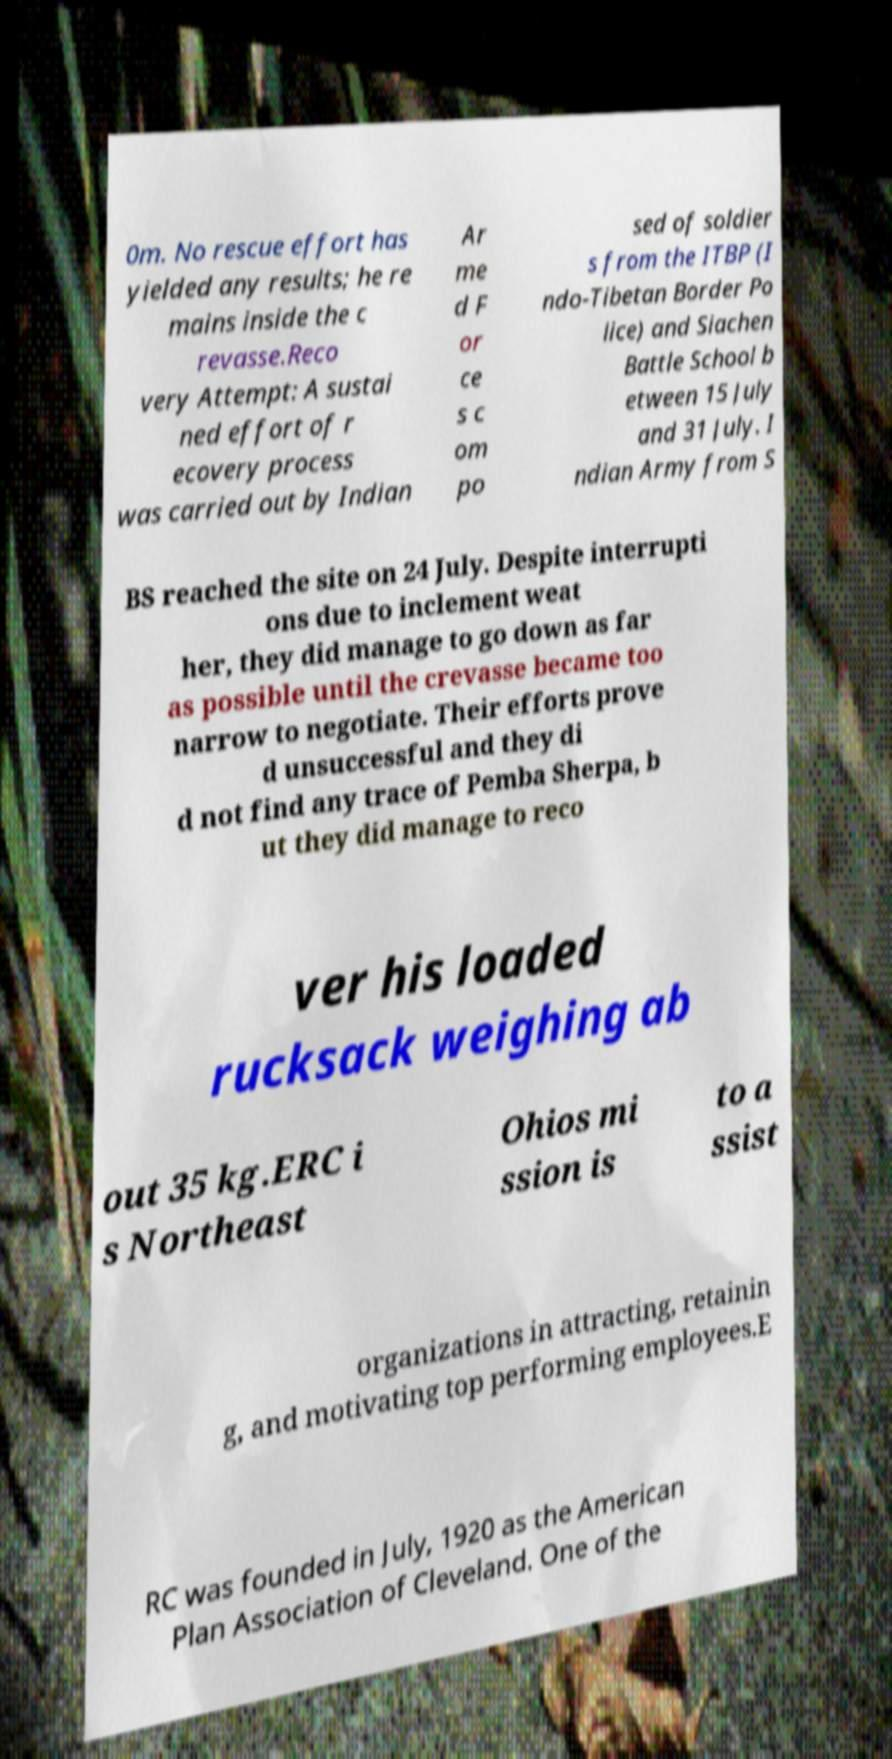Can you accurately transcribe the text from the provided image for me? 0m. No rescue effort has yielded any results; he re mains inside the c revasse.Reco very Attempt: A sustai ned effort of r ecovery process was carried out by Indian Ar me d F or ce s c om po sed of soldier s from the ITBP (I ndo-Tibetan Border Po lice) and Siachen Battle School b etween 15 July and 31 July. I ndian Army from S BS reached the site on 24 July. Despite interrupti ons due to inclement weat her, they did manage to go down as far as possible until the crevasse became too narrow to negotiate. Their efforts prove d unsuccessful and they di d not find any trace of Pemba Sherpa, b ut they did manage to reco ver his loaded rucksack weighing ab out 35 kg.ERC i s Northeast Ohios mi ssion is to a ssist organizations in attracting, retainin g, and motivating top performing employees.E RC was founded in July, 1920 as the American Plan Association of Cleveland. One of the 